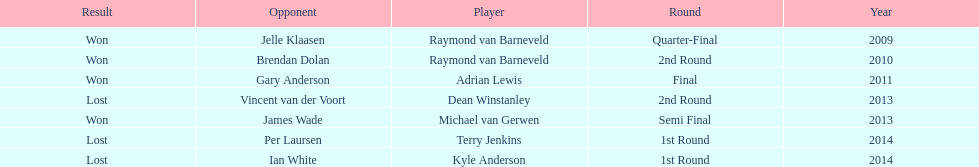Who are all the players? Raymond van Barneveld, Raymond van Barneveld, Adrian Lewis, Dean Winstanley, Michael van Gerwen, Terry Jenkins, Kyle Anderson. When did they play? 2009, 2010, 2011, 2013, 2013, 2014, 2014. And which player played in 2011? Adrian Lewis. 